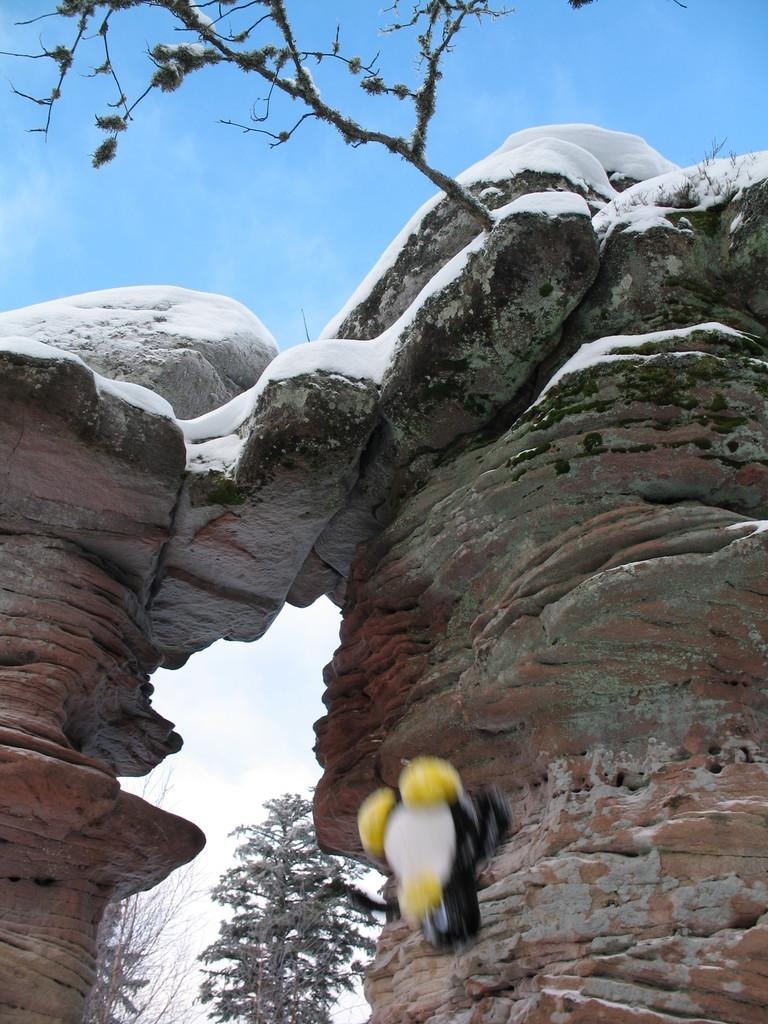What type of natural formation is visible in the image? There is a mountain in the image. What other natural elements can be seen in the image? There are trees in the image. Can you describe the bird at the bottom of the image? The bird has black, white, and yellow colors. Who is the owner of the mountain in the image? There is no owner of the mountain in the image, as it is a natural formation. Can you describe the bird's eyes in the image? The provided facts do not mention the bird's eyes, so we cannot describe them. 